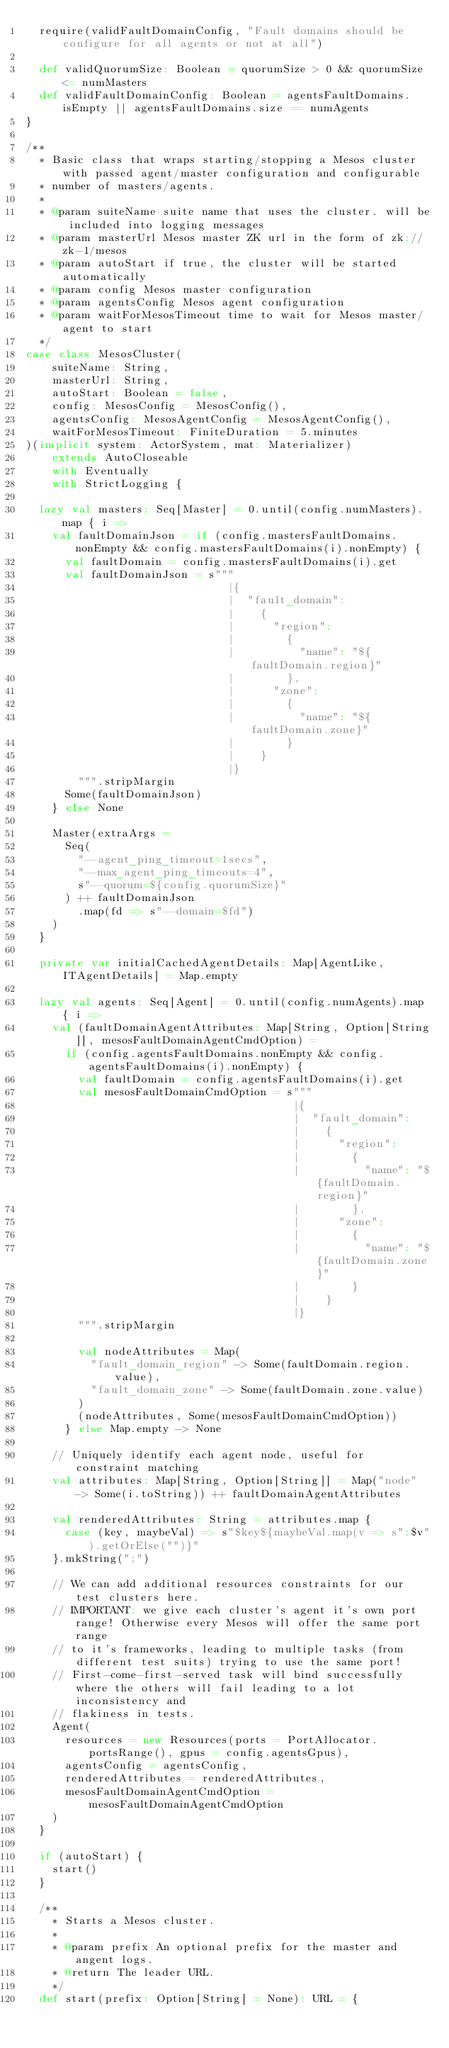<code> <loc_0><loc_0><loc_500><loc_500><_Scala_>  require(validFaultDomainConfig, "Fault domains should be configure for all agents or not at all")

  def validQuorumSize: Boolean = quorumSize > 0 && quorumSize <= numMasters
  def validFaultDomainConfig: Boolean = agentsFaultDomains.isEmpty || agentsFaultDomains.size == numAgents
}

/**
  * Basic class that wraps starting/stopping a Mesos cluster with passed agent/master configuration and configurable
  * number of masters/agents.
  *
  * @param suiteName suite name that uses the cluster. will be included into logging messages
  * @param masterUrl Mesos master ZK url in the form of zk://zk-1/mesos
  * @param autoStart if true, the cluster will be started automatically
  * @param config Mesos master configuration
  * @param agentsConfig Mesos agent configuration
  * @param waitForMesosTimeout time to wait for Mesos master/agent to start
  */
case class MesosCluster(
    suiteName: String,
    masterUrl: String,
    autoStart: Boolean = false,
    config: MesosConfig = MesosConfig(),
    agentsConfig: MesosAgentConfig = MesosAgentConfig(),
    waitForMesosTimeout: FiniteDuration = 5.minutes
)(implicit system: ActorSystem, mat: Materializer)
    extends AutoCloseable
    with Eventually
    with StrictLogging {

  lazy val masters: Seq[Master] = 0.until(config.numMasters).map { i =>
    val faultDomainJson = if (config.mastersFaultDomains.nonEmpty && config.mastersFaultDomains(i).nonEmpty) {
      val faultDomain = config.mastersFaultDomains(i).get
      val faultDomainJson = s"""
                               |{
                               |  "fault_domain":
                               |    {
                               |      "region":
                               |        {
                               |          "name": "${faultDomain.region}"
                               |        },
                               |      "zone":
                               |        {
                               |          "name": "${faultDomain.zone}"
                               |        }
                               |    }
                               |}
        """.stripMargin
      Some(faultDomainJson)
    } else None

    Master(extraArgs =
      Seq(
        "--agent_ping_timeout=1secs",
        "--max_agent_ping_timeouts=4",
        s"--quorum=${config.quorumSize}"
      ) ++ faultDomainJson
        .map(fd => s"--domain=$fd")
    )
  }

  private var initialCachedAgentDetails: Map[AgentLike, ITAgentDetails] = Map.empty

  lazy val agents: Seq[Agent] = 0.until(config.numAgents).map { i =>
    val (faultDomainAgentAttributes: Map[String, Option[String]], mesosFaultDomainAgentCmdOption) =
      if (config.agentsFaultDomains.nonEmpty && config.agentsFaultDomains(i).nonEmpty) {
        val faultDomain = config.agentsFaultDomains(i).get
        val mesosFaultDomainCmdOption = s"""
                                         |{
                                         |  "fault_domain":
                                         |    {
                                         |      "region":
                                         |        {
                                         |          "name": "${faultDomain.region}"
                                         |        },
                                         |      "zone":
                                         |        {
                                         |          "name": "${faultDomain.zone}"
                                         |        }
                                         |    }
                                         |}
        """.stripMargin

        val nodeAttributes = Map(
          "fault_domain_region" -> Some(faultDomain.region.value),
          "fault_domain_zone" -> Some(faultDomain.zone.value)
        )
        (nodeAttributes, Some(mesosFaultDomainCmdOption))
      } else Map.empty -> None

    // Uniquely identify each agent node, useful for constraint matching
    val attributes: Map[String, Option[String]] = Map("node" -> Some(i.toString)) ++ faultDomainAgentAttributes

    val renderedAttributes: String = attributes.map {
      case (key, maybeVal) => s"$key${maybeVal.map(v => s":$v").getOrElse("")}"
    }.mkString(";")

    // We can add additional resources constraints for our test clusters here.
    // IMPORTANT: we give each cluster's agent it's own port range! Otherwise every Mesos will offer the same port range
    // to it's frameworks, leading to multiple tasks (from different test suits) trying to use the same port!
    // First-come-first-served task will bind successfully where the others will fail leading to a lot inconsistency and
    // flakiness in tests.
    Agent(
      resources = new Resources(ports = PortAllocator.portsRange(), gpus = config.agentsGpus),
      agentsConfig = agentsConfig,
      renderedAttributes = renderedAttributes,
      mesosFaultDomainAgentCmdOption = mesosFaultDomainAgentCmdOption
    )
  }

  if (autoStart) {
    start()
  }

  /**
    * Starts a Mesos cluster.
    *
    * @param prefix An optional prefix for the master and angent logs.
    * @return The leader URL.
    */
  def start(prefix: Option[String] = None): URL = {</code> 